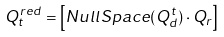Convert formula to latex. <formula><loc_0><loc_0><loc_500><loc_500>Q ^ { r e d } _ { t } = \left [ { N u l l S p a c e } ( Q _ { d } ^ { t } ) \cdot Q _ { r } \right ]</formula> 